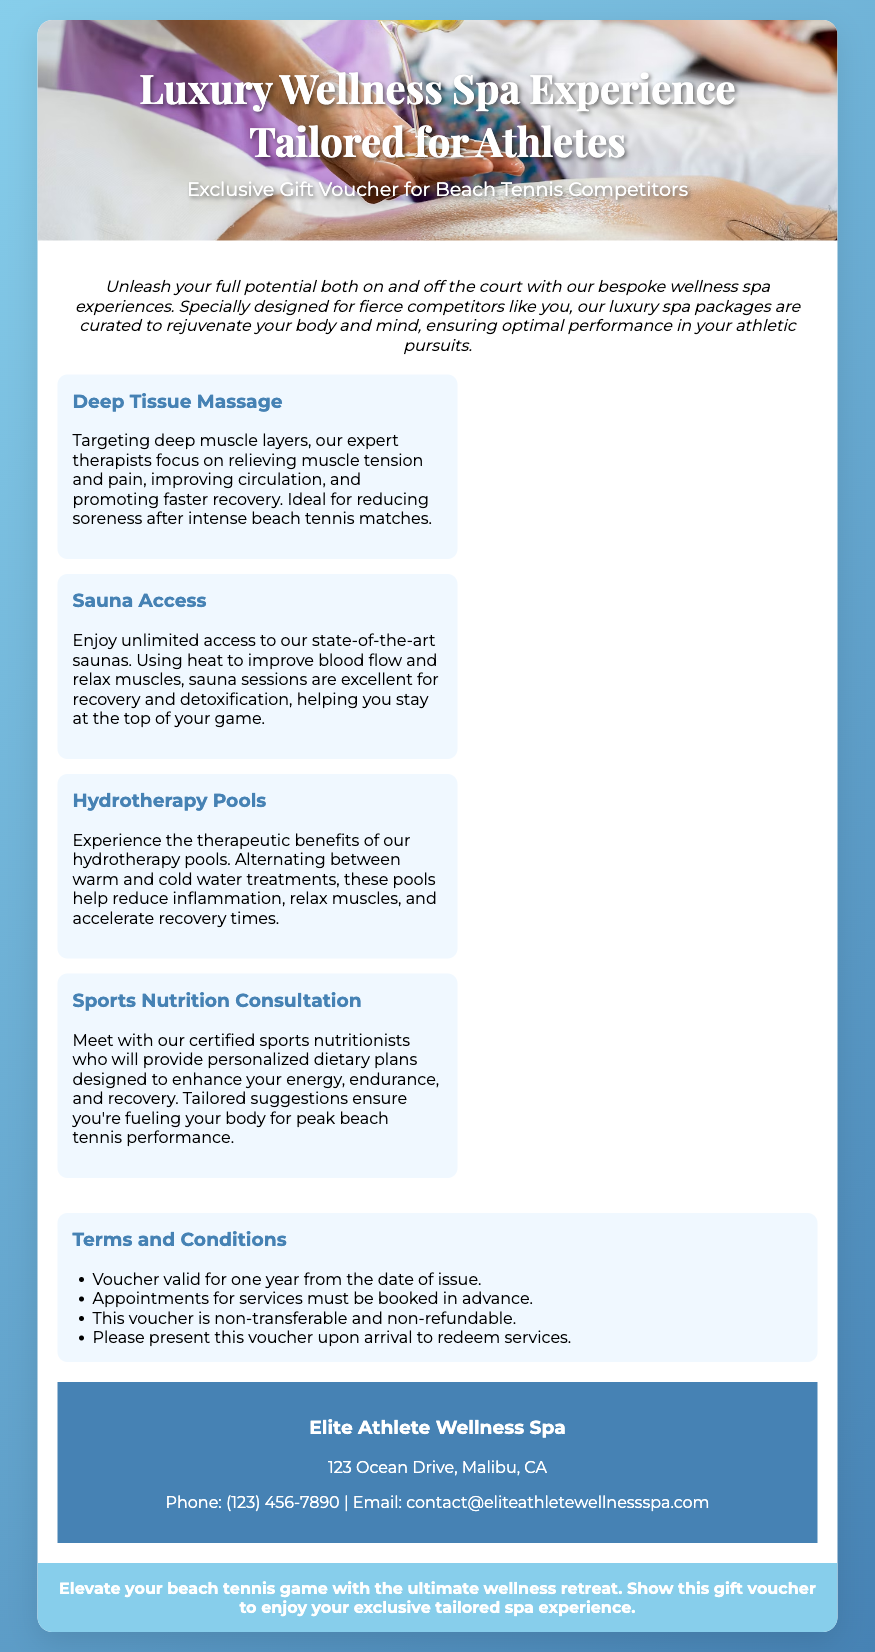What is the title of the voucher? The title of the voucher is prominently displayed at the top of the document, which is "Luxury Wellness Spa Experience Tailored for Athletes".
Answer: Luxury Wellness Spa Experience Tailored for Athletes What type of massage is included in the voucher? The voucher specifically highlights a service that features "Deep Tissue Massage" which is aimed at relieving muscle tension.
Answer: Deep Tissue Massage Where is the wellness spa located? The address of the spa is given in the issuer section of the document, which states "123 Ocean Drive, Malibu, CA".
Answer: 123 Ocean Drive, Malibu, CA What must be done in advance to use the services? The terms and conditions section specifies that "Appointments for services must be booked in advance."
Answer: Appointments for services must be booked in advance How long is the voucher valid? The terms state that the "Voucher valid for one year from the date of issue," providing a clear time frame for its usability.
Answer: One year What service helps with recovery after beach tennis matches? The document emphasizes that "Deep Tissue Massage" is ideal for reducing soreness after intense beach tennis matches.
Answer: Deep Tissue Massage Who can benefit from the sports nutrition consultation? The description mentions that the service is provided by "certified sports nutritionists," suggesting tailored advice for athletes.
Answer: Athletes Is the voucher transferable? The terms and conditions clearly state that "This voucher is non-transferable and non-refundable," indicating its personal use only.
Answer: Non-transferable What color is the background gradient of the voucher? The document description reveals that the background has a gradient of light and dark blue colors, specifically "linear-gradient(135deg, #87CEEB, #4682B4)".
Answer: Light and dark blue 